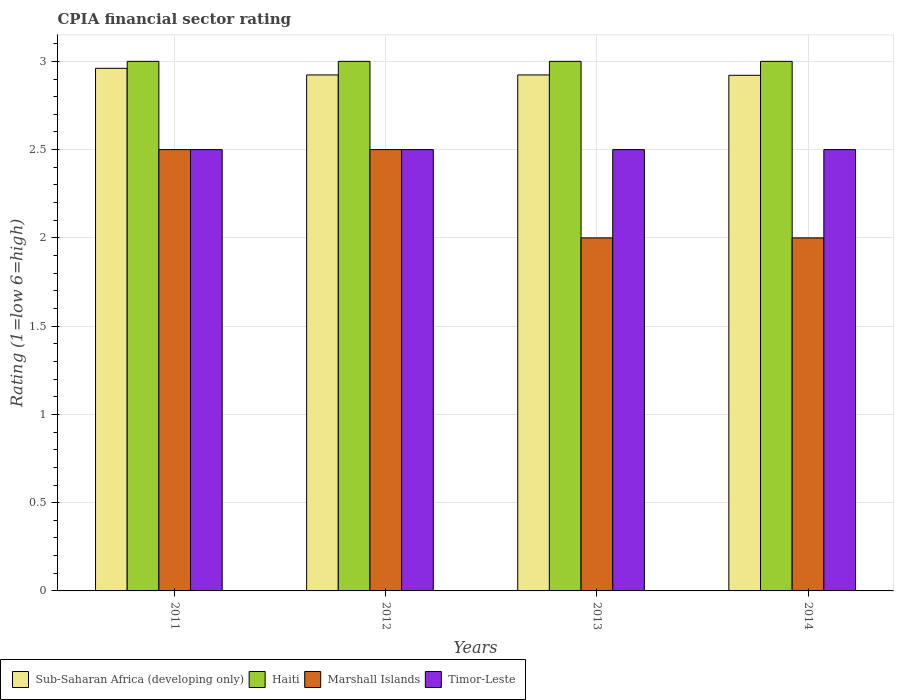How many different coloured bars are there?
Keep it short and to the point. 4. Are the number of bars per tick equal to the number of legend labels?
Keep it short and to the point. Yes. How many bars are there on the 1st tick from the right?
Provide a short and direct response. 4. What is the label of the 3rd group of bars from the left?
Offer a terse response. 2013. What is the CPIA rating in Timor-Leste in 2013?
Give a very brief answer. 2.5. Across all years, what is the maximum CPIA rating in Timor-Leste?
Make the answer very short. 2.5. Across all years, what is the minimum CPIA rating in Timor-Leste?
Make the answer very short. 2.5. In which year was the CPIA rating in Marshall Islands minimum?
Provide a short and direct response. 2013. What is the average CPIA rating in Sub-Saharan Africa (developing only) per year?
Make the answer very short. 2.93. What is the ratio of the CPIA rating in Marshall Islands in 2012 to that in 2014?
Provide a succinct answer. 1.25. Is the CPIA rating in Sub-Saharan Africa (developing only) in 2011 less than that in 2014?
Ensure brevity in your answer.  No. Is the difference between the CPIA rating in Haiti in 2012 and 2014 greater than the difference between the CPIA rating in Timor-Leste in 2012 and 2014?
Offer a very short reply. No. What is the difference between the highest and the second highest CPIA rating in Timor-Leste?
Make the answer very short. 0. What does the 2nd bar from the left in 2013 represents?
Provide a short and direct response. Haiti. What does the 4th bar from the right in 2014 represents?
Your answer should be very brief. Sub-Saharan Africa (developing only). How many bars are there?
Make the answer very short. 16. Are all the bars in the graph horizontal?
Provide a short and direct response. No. How many years are there in the graph?
Keep it short and to the point. 4. What is the difference between two consecutive major ticks on the Y-axis?
Your response must be concise. 0.5. Does the graph contain any zero values?
Provide a short and direct response. No. Does the graph contain grids?
Ensure brevity in your answer.  Yes. How many legend labels are there?
Ensure brevity in your answer.  4. What is the title of the graph?
Your answer should be compact. CPIA financial sector rating. What is the label or title of the Y-axis?
Your answer should be compact. Rating (1=low 6=high). What is the Rating (1=low 6=high) in Sub-Saharan Africa (developing only) in 2011?
Your response must be concise. 2.96. What is the Rating (1=low 6=high) of Marshall Islands in 2011?
Make the answer very short. 2.5. What is the Rating (1=low 6=high) of Timor-Leste in 2011?
Your response must be concise. 2.5. What is the Rating (1=low 6=high) of Sub-Saharan Africa (developing only) in 2012?
Make the answer very short. 2.92. What is the Rating (1=low 6=high) in Haiti in 2012?
Your answer should be very brief. 3. What is the Rating (1=low 6=high) of Timor-Leste in 2012?
Ensure brevity in your answer.  2.5. What is the Rating (1=low 6=high) in Sub-Saharan Africa (developing only) in 2013?
Your answer should be compact. 2.92. What is the Rating (1=low 6=high) of Haiti in 2013?
Offer a terse response. 3. What is the Rating (1=low 6=high) of Marshall Islands in 2013?
Provide a short and direct response. 2. What is the Rating (1=low 6=high) of Timor-Leste in 2013?
Ensure brevity in your answer.  2.5. What is the Rating (1=low 6=high) of Sub-Saharan Africa (developing only) in 2014?
Offer a very short reply. 2.92. What is the Rating (1=low 6=high) of Marshall Islands in 2014?
Offer a very short reply. 2. What is the Rating (1=low 6=high) of Timor-Leste in 2014?
Make the answer very short. 2.5. Across all years, what is the maximum Rating (1=low 6=high) of Sub-Saharan Africa (developing only)?
Give a very brief answer. 2.96. Across all years, what is the maximum Rating (1=low 6=high) in Timor-Leste?
Offer a very short reply. 2.5. Across all years, what is the minimum Rating (1=low 6=high) in Sub-Saharan Africa (developing only)?
Keep it short and to the point. 2.92. Across all years, what is the minimum Rating (1=low 6=high) of Marshall Islands?
Make the answer very short. 2. What is the total Rating (1=low 6=high) of Sub-Saharan Africa (developing only) in the graph?
Ensure brevity in your answer.  11.73. What is the difference between the Rating (1=low 6=high) in Sub-Saharan Africa (developing only) in 2011 and that in 2012?
Keep it short and to the point. 0.04. What is the difference between the Rating (1=low 6=high) in Haiti in 2011 and that in 2012?
Ensure brevity in your answer.  0. What is the difference between the Rating (1=low 6=high) in Timor-Leste in 2011 and that in 2012?
Your answer should be very brief. 0. What is the difference between the Rating (1=low 6=high) of Sub-Saharan Africa (developing only) in 2011 and that in 2013?
Ensure brevity in your answer.  0.04. What is the difference between the Rating (1=low 6=high) of Marshall Islands in 2011 and that in 2013?
Provide a succinct answer. 0.5. What is the difference between the Rating (1=low 6=high) in Sub-Saharan Africa (developing only) in 2011 and that in 2014?
Keep it short and to the point. 0.04. What is the difference between the Rating (1=low 6=high) in Timor-Leste in 2012 and that in 2013?
Your response must be concise. 0. What is the difference between the Rating (1=low 6=high) of Sub-Saharan Africa (developing only) in 2012 and that in 2014?
Ensure brevity in your answer.  0. What is the difference between the Rating (1=low 6=high) in Haiti in 2012 and that in 2014?
Ensure brevity in your answer.  0. What is the difference between the Rating (1=low 6=high) of Sub-Saharan Africa (developing only) in 2013 and that in 2014?
Provide a short and direct response. 0. What is the difference between the Rating (1=low 6=high) of Timor-Leste in 2013 and that in 2014?
Provide a succinct answer. 0. What is the difference between the Rating (1=low 6=high) of Sub-Saharan Africa (developing only) in 2011 and the Rating (1=low 6=high) of Haiti in 2012?
Give a very brief answer. -0.04. What is the difference between the Rating (1=low 6=high) of Sub-Saharan Africa (developing only) in 2011 and the Rating (1=low 6=high) of Marshall Islands in 2012?
Provide a short and direct response. 0.46. What is the difference between the Rating (1=low 6=high) of Sub-Saharan Africa (developing only) in 2011 and the Rating (1=low 6=high) of Timor-Leste in 2012?
Give a very brief answer. 0.46. What is the difference between the Rating (1=low 6=high) of Haiti in 2011 and the Rating (1=low 6=high) of Marshall Islands in 2012?
Your answer should be compact. 0.5. What is the difference between the Rating (1=low 6=high) of Haiti in 2011 and the Rating (1=low 6=high) of Timor-Leste in 2012?
Your answer should be compact. 0.5. What is the difference between the Rating (1=low 6=high) of Sub-Saharan Africa (developing only) in 2011 and the Rating (1=low 6=high) of Haiti in 2013?
Keep it short and to the point. -0.04. What is the difference between the Rating (1=low 6=high) of Sub-Saharan Africa (developing only) in 2011 and the Rating (1=low 6=high) of Marshall Islands in 2013?
Offer a very short reply. 0.96. What is the difference between the Rating (1=low 6=high) of Sub-Saharan Africa (developing only) in 2011 and the Rating (1=low 6=high) of Timor-Leste in 2013?
Offer a very short reply. 0.46. What is the difference between the Rating (1=low 6=high) of Haiti in 2011 and the Rating (1=low 6=high) of Marshall Islands in 2013?
Provide a succinct answer. 1. What is the difference between the Rating (1=low 6=high) in Haiti in 2011 and the Rating (1=low 6=high) in Timor-Leste in 2013?
Provide a short and direct response. 0.5. What is the difference between the Rating (1=low 6=high) of Sub-Saharan Africa (developing only) in 2011 and the Rating (1=low 6=high) of Haiti in 2014?
Offer a terse response. -0.04. What is the difference between the Rating (1=low 6=high) of Sub-Saharan Africa (developing only) in 2011 and the Rating (1=low 6=high) of Marshall Islands in 2014?
Your response must be concise. 0.96. What is the difference between the Rating (1=low 6=high) of Sub-Saharan Africa (developing only) in 2011 and the Rating (1=low 6=high) of Timor-Leste in 2014?
Provide a succinct answer. 0.46. What is the difference between the Rating (1=low 6=high) in Haiti in 2011 and the Rating (1=low 6=high) in Timor-Leste in 2014?
Make the answer very short. 0.5. What is the difference between the Rating (1=low 6=high) of Sub-Saharan Africa (developing only) in 2012 and the Rating (1=low 6=high) of Haiti in 2013?
Make the answer very short. -0.08. What is the difference between the Rating (1=low 6=high) in Sub-Saharan Africa (developing only) in 2012 and the Rating (1=low 6=high) in Marshall Islands in 2013?
Offer a very short reply. 0.92. What is the difference between the Rating (1=low 6=high) in Sub-Saharan Africa (developing only) in 2012 and the Rating (1=low 6=high) in Timor-Leste in 2013?
Ensure brevity in your answer.  0.42. What is the difference between the Rating (1=low 6=high) of Haiti in 2012 and the Rating (1=low 6=high) of Marshall Islands in 2013?
Make the answer very short. 1. What is the difference between the Rating (1=low 6=high) in Marshall Islands in 2012 and the Rating (1=low 6=high) in Timor-Leste in 2013?
Your answer should be very brief. 0. What is the difference between the Rating (1=low 6=high) in Sub-Saharan Africa (developing only) in 2012 and the Rating (1=low 6=high) in Haiti in 2014?
Provide a short and direct response. -0.08. What is the difference between the Rating (1=low 6=high) in Sub-Saharan Africa (developing only) in 2012 and the Rating (1=low 6=high) in Timor-Leste in 2014?
Make the answer very short. 0.42. What is the difference between the Rating (1=low 6=high) in Haiti in 2012 and the Rating (1=low 6=high) in Marshall Islands in 2014?
Keep it short and to the point. 1. What is the difference between the Rating (1=low 6=high) of Marshall Islands in 2012 and the Rating (1=low 6=high) of Timor-Leste in 2014?
Ensure brevity in your answer.  0. What is the difference between the Rating (1=low 6=high) of Sub-Saharan Africa (developing only) in 2013 and the Rating (1=low 6=high) of Haiti in 2014?
Keep it short and to the point. -0.08. What is the difference between the Rating (1=low 6=high) of Sub-Saharan Africa (developing only) in 2013 and the Rating (1=low 6=high) of Timor-Leste in 2014?
Keep it short and to the point. 0.42. What is the average Rating (1=low 6=high) of Sub-Saharan Africa (developing only) per year?
Your answer should be compact. 2.93. What is the average Rating (1=low 6=high) in Marshall Islands per year?
Ensure brevity in your answer.  2.25. In the year 2011, what is the difference between the Rating (1=low 6=high) of Sub-Saharan Africa (developing only) and Rating (1=low 6=high) of Haiti?
Give a very brief answer. -0.04. In the year 2011, what is the difference between the Rating (1=low 6=high) of Sub-Saharan Africa (developing only) and Rating (1=low 6=high) of Marshall Islands?
Your answer should be compact. 0.46. In the year 2011, what is the difference between the Rating (1=low 6=high) of Sub-Saharan Africa (developing only) and Rating (1=low 6=high) of Timor-Leste?
Offer a terse response. 0.46. In the year 2011, what is the difference between the Rating (1=low 6=high) in Marshall Islands and Rating (1=low 6=high) in Timor-Leste?
Keep it short and to the point. 0. In the year 2012, what is the difference between the Rating (1=low 6=high) in Sub-Saharan Africa (developing only) and Rating (1=low 6=high) in Haiti?
Provide a succinct answer. -0.08. In the year 2012, what is the difference between the Rating (1=low 6=high) in Sub-Saharan Africa (developing only) and Rating (1=low 6=high) in Marshall Islands?
Keep it short and to the point. 0.42. In the year 2012, what is the difference between the Rating (1=low 6=high) in Sub-Saharan Africa (developing only) and Rating (1=low 6=high) in Timor-Leste?
Provide a succinct answer. 0.42. In the year 2012, what is the difference between the Rating (1=low 6=high) in Haiti and Rating (1=low 6=high) in Timor-Leste?
Give a very brief answer. 0.5. In the year 2013, what is the difference between the Rating (1=low 6=high) of Sub-Saharan Africa (developing only) and Rating (1=low 6=high) of Haiti?
Ensure brevity in your answer.  -0.08. In the year 2013, what is the difference between the Rating (1=low 6=high) of Sub-Saharan Africa (developing only) and Rating (1=low 6=high) of Marshall Islands?
Your response must be concise. 0.92. In the year 2013, what is the difference between the Rating (1=low 6=high) in Sub-Saharan Africa (developing only) and Rating (1=low 6=high) in Timor-Leste?
Your answer should be very brief. 0.42. In the year 2013, what is the difference between the Rating (1=low 6=high) of Haiti and Rating (1=low 6=high) of Timor-Leste?
Ensure brevity in your answer.  0.5. In the year 2013, what is the difference between the Rating (1=low 6=high) of Marshall Islands and Rating (1=low 6=high) of Timor-Leste?
Provide a short and direct response. -0.5. In the year 2014, what is the difference between the Rating (1=low 6=high) in Sub-Saharan Africa (developing only) and Rating (1=low 6=high) in Haiti?
Make the answer very short. -0.08. In the year 2014, what is the difference between the Rating (1=low 6=high) in Sub-Saharan Africa (developing only) and Rating (1=low 6=high) in Marshall Islands?
Keep it short and to the point. 0.92. In the year 2014, what is the difference between the Rating (1=low 6=high) in Sub-Saharan Africa (developing only) and Rating (1=low 6=high) in Timor-Leste?
Your response must be concise. 0.42. In the year 2014, what is the difference between the Rating (1=low 6=high) in Haiti and Rating (1=low 6=high) in Marshall Islands?
Ensure brevity in your answer.  1. In the year 2014, what is the difference between the Rating (1=low 6=high) of Haiti and Rating (1=low 6=high) of Timor-Leste?
Offer a terse response. 0.5. What is the ratio of the Rating (1=low 6=high) in Sub-Saharan Africa (developing only) in 2011 to that in 2012?
Ensure brevity in your answer.  1.01. What is the ratio of the Rating (1=low 6=high) of Haiti in 2011 to that in 2012?
Keep it short and to the point. 1. What is the ratio of the Rating (1=low 6=high) in Marshall Islands in 2011 to that in 2012?
Keep it short and to the point. 1. What is the ratio of the Rating (1=low 6=high) in Sub-Saharan Africa (developing only) in 2011 to that in 2013?
Ensure brevity in your answer.  1.01. What is the ratio of the Rating (1=low 6=high) of Haiti in 2011 to that in 2013?
Provide a succinct answer. 1. What is the ratio of the Rating (1=low 6=high) in Marshall Islands in 2011 to that in 2013?
Offer a terse response. 1.25. What is the ratio of the Rating (1=low 6=high) in Timor-Leste in 2011 to that in 2013?
Your answer should be very brief. 1. What is the ratio of the Rating (1=low 6=high) of Sub-Saharan Africa (developing only) in 2011 to that in 2014?
Offer a terse response. 1.01. What is the ratio of the Rating (1=low 6=high) of Haiti in 2011 to that in 2014?
Offer a terse response. 1. What is the ratio of the Rating (1=low 6=high) of Marshall Islands in 2011 to that in 2014?
Your answer should be very brief. 1.25. What is the ratio of the Rating (1=low 6=high) of Sub-Saharan Africa (developing only) in 2012 to that in 2013?
Provide a short and direct response. 1. What is the ratio of the Rating (1=low 6=high) in Haiti in 2012 to that in 2013?
Offer a terse response. 1. What is the ratio of the Rating (1=low 6=high) of Sub-Saharan Africa (developing only) in 2012 to that in 2014?
Offer a very short reply. 1. What is the ratio of the Rating (1=low 6=high) in Haiti in 2012 to that in 2014?
Provide a succinct answer. 1. What is the ratio of the Rating (1=low 6=high) of Sub-Saharan Africa (developing only) in 2013 to that in 2014?
Provide a succinct answer. 1. What is the ratio of the Rating (1=low 6=high) of Haiti in 2013 to that in 2014?
Keep it short and to the point. 1. What is the ratio of the Rating (1=low 6=high) of Marshall Islands in 2013 to that in 2014?
Your response must be concise. 1. What is the difference between the highest and the second highest Rating (1=low 6=high) of Sub-Saharan Africa (developing only)?
Your response must be concise. 0.04. What is the difference between the highest and the second highest Rating (1=low 6=high) of Marshall Islands?
Give a very brief answer. 0. What is the difference between the highest and the lowest Rating (1=low 6=high) of Sub-Saharan Africa (developing only)?
Keep it short and to the point. 0.04. What is the difference between the highest and the lowest Rating (1=low 6=high) of Haiti?
Ensure brevity in your answer.  0. What is the difference between the highest and the lowest Rating (1=low 6=high) of Marshall Islands?
Make the answer very short. 0.5. What is the difference between the highest and the lowest Rating (1=low 6=high) in Timor-Leste?
Offer a terse response. 0. 